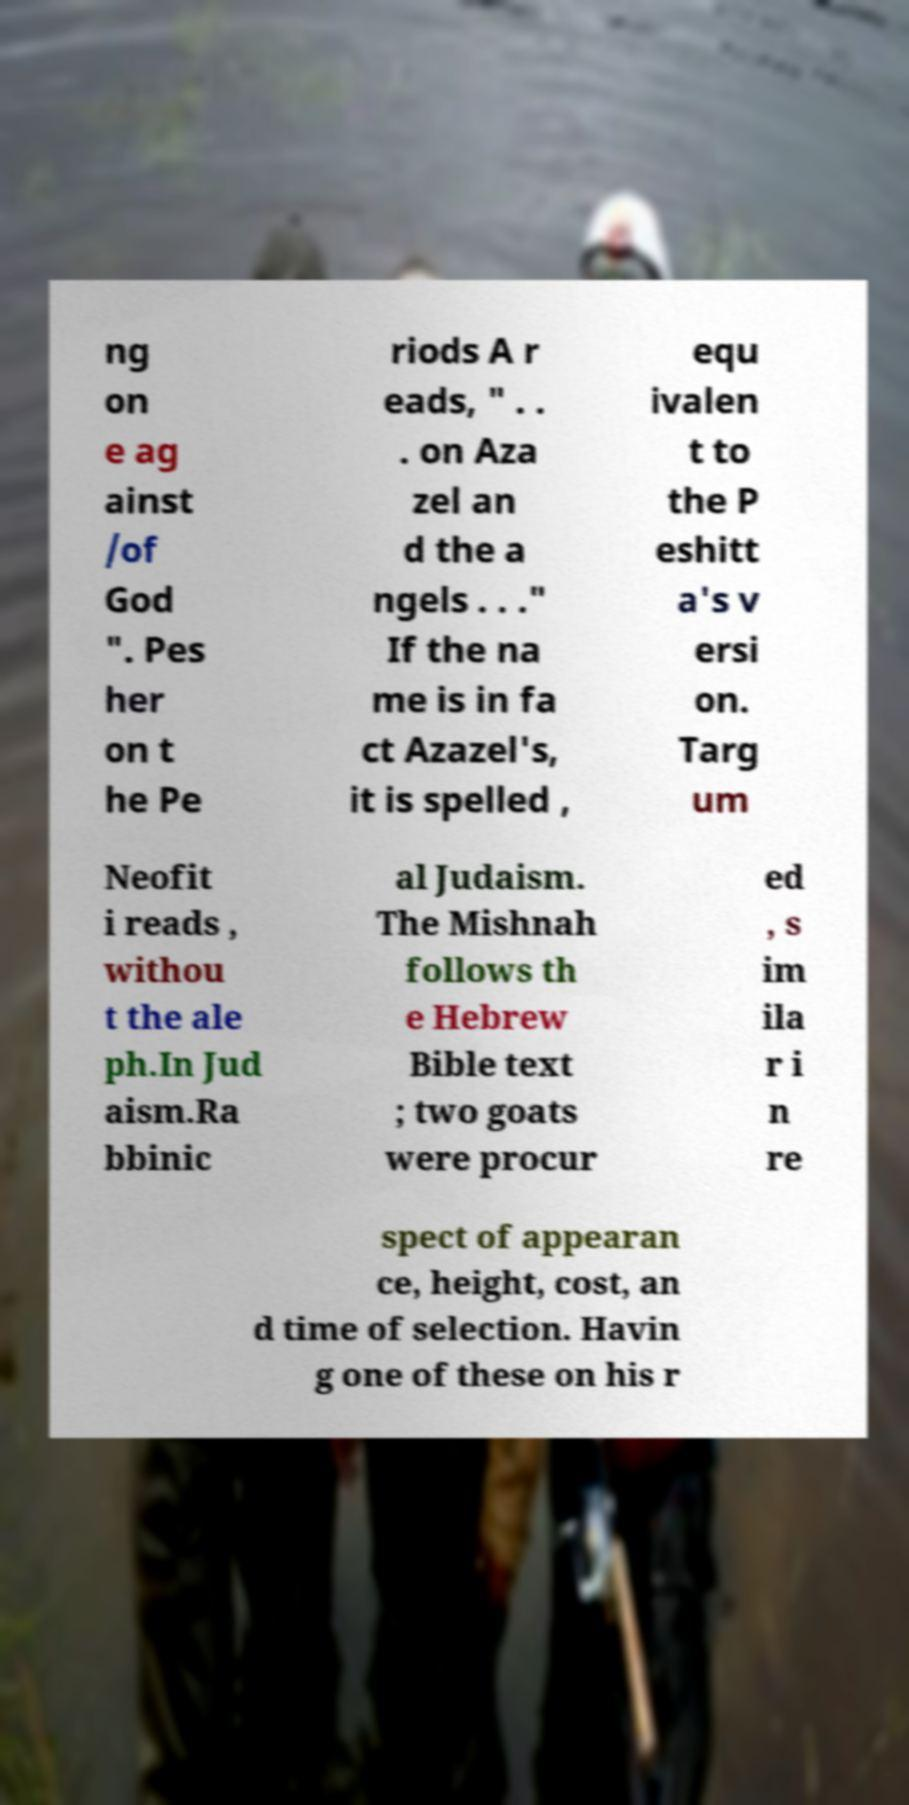What messages or text are displayed in this image? I need them in a readable, typed format. ng on e ag ainst /of God ". Pes her on t he Pe riods A r eads, " . . . on Aza zel an d the a ngels . . ." If the na me is in fa ct Azazel's, it is spelled , equ ivalen t to the P eshitt a's v ersi on. Targ um Neofit i reads , withou t the ale ph.In Jud aism.Ra bbinic al Judaism. The Mishnah follows th e Hebrew Bible text ; two goats were procur ed , s im ila r i n re spect of appearan ce, height, cost, an d time of selection. Havin g one of these on his r 